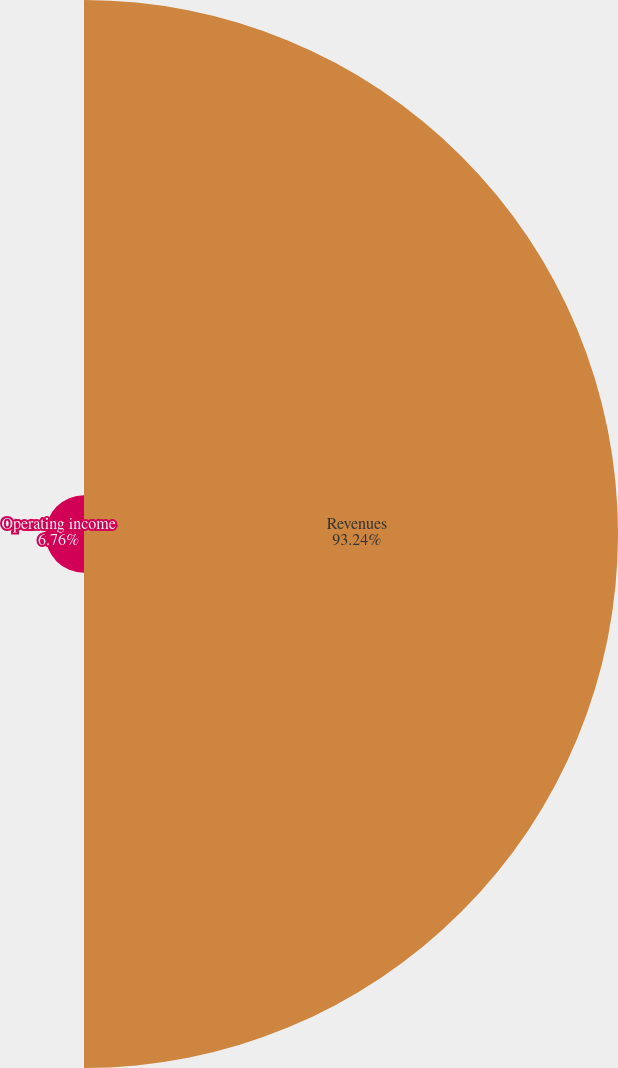Convert chart. <chart><loc_0><loc_0><loc_500><loc_500><pie_chart><fcel>Revenues<fcel>Operating income<nl><fcel>93.24%<fcel>6.76%<nl></chart> 